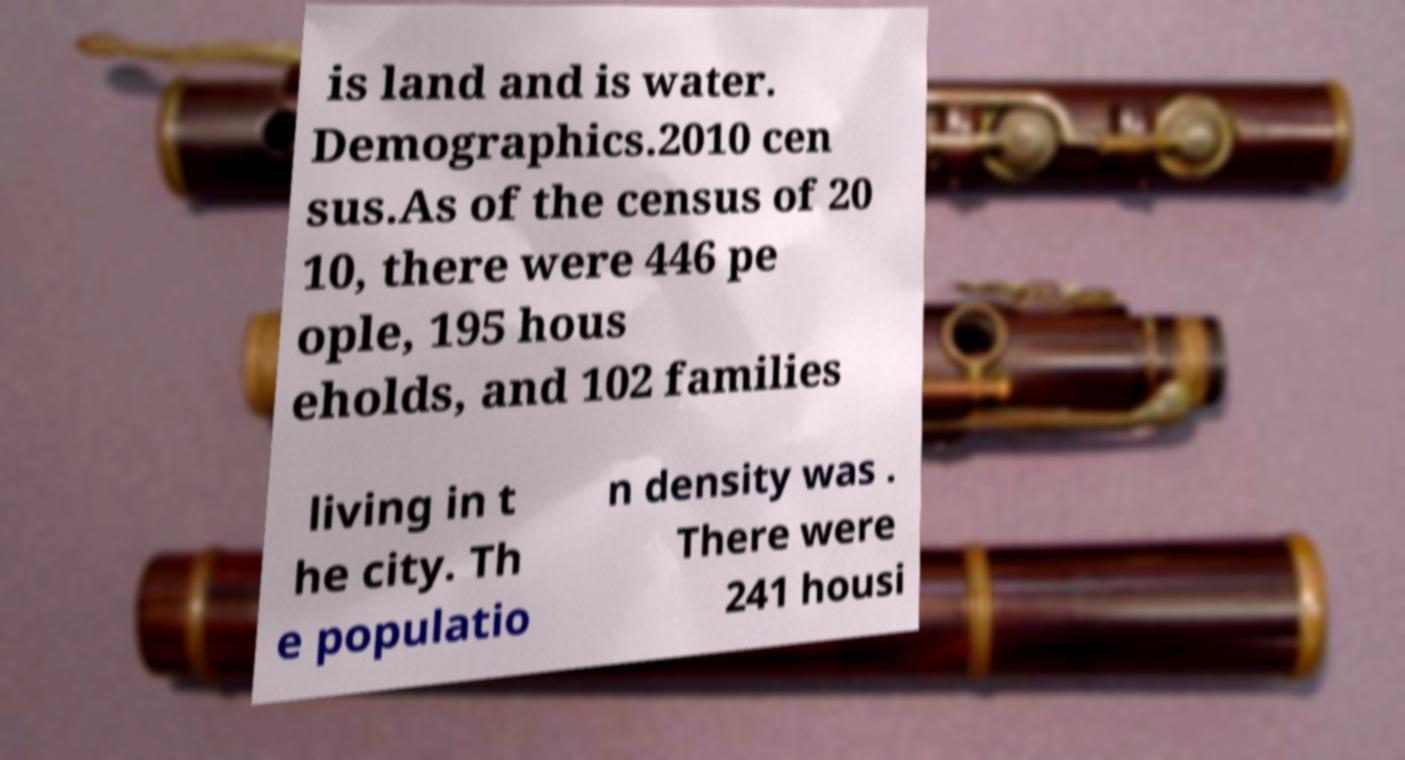Please identify and transcribe the text found in this image. is land and is water. Demographics.2010 cen sus.As of the census of 20 10, there were 446 pe ople, 195 hous eholds, and 102 families living in t he city. Th e populatio n density was . There were 241 housi 